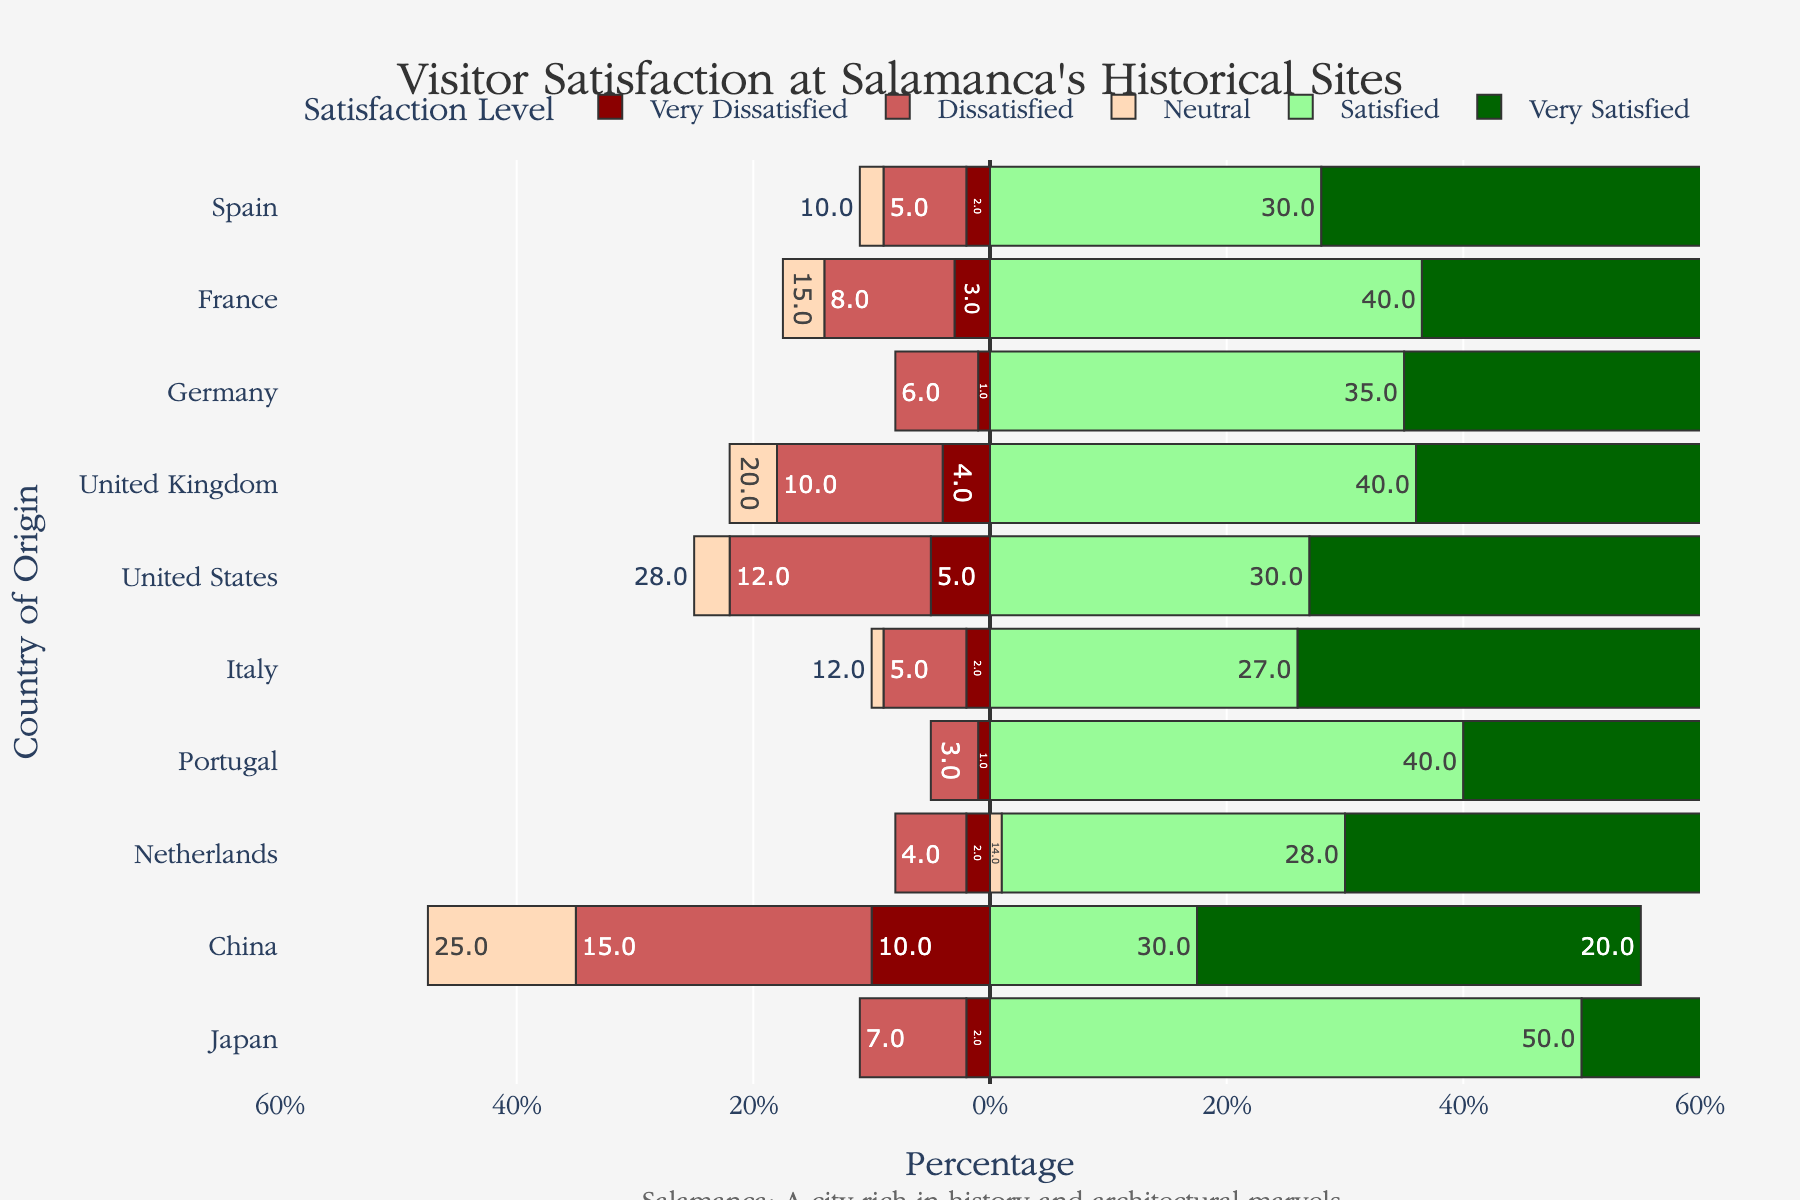How many countries have a higher percentage of Very Satisfied visitors than Satisfied visitors? To find the answer, we need to compare the percentage of Very Satisfied visitors to Satisfied visitors for each country. The countries which have a higher percentage of Very Satisfied visitors than Satisfied are: Spain, Italy, Portugal, and Netherlands.
Answer: 4 Which country has the highest percentage of Very Dissatisfied visitors, and what is the percentage? Identify the bar with the largest negative value for Very Dissatisfied visitors. China has the highest percentage of Very Dissatisfied visitors at 10%.
Answer: China, 10% Among the countries listed, who has the lowest percentage of Neutral visitors? Compare the percentage values of the Neutral visitors for all the countries. Portugal has the lowest percentage of Neutral visitors at 8%.
Answer: Portugal, 8% What is the total percentage of visitors from the United States who are either Satisfied or Very Satisfied? Add the percentages of Satisfied and Very Satisfied visitors from the United States. The sum is 30% + 25% = 55%.
Answer: 55% Which two countries have the closest percentages of Dissatisfied visitors, and what is the difference? Compare the percentages of Dissatisfied visitors for all countries and find two closest values. Spain and Italy both have 5%, which means the difference is 0%.
Answer: Spain and Italy, 0% Rank the countries from highest to lowest based on the percentage of Very Satisfied visitors. List the percentage of Very Satisfied visitors for each country and sort them in descending order: Italy (54%), Spain (53%), Netherlands (52%), Portugal (48%), Germany (44%), France (34%), United Kingdom (26%), Japan (23%), United States (25%), China (20%).
Answer: Italy, Spain, Netherlands, Portugal, Germany, France, United Kingdom, Japan, United States, China Which country has the smallest combined percentage of Very Dissatisfied and Dissatisfied visitors? Add the percentages of Very Dissatisfied and Dissatisfied visitors for each country and identify the smallest sum. Portugal has the smallest combined percentage (1% + 3% = 4%).
Answer: Portugal What's the percentage of neutral visitors from France and Japan combined? Add the percentages of Neutral visitors from France and Japan. The sum is 15% + 18% = 33%.
Answer: 33% Is there any country where the majority of visitors (over 50%) are Very Satisfied? Check each country's percentage of Very Satisfied visitors to see if any exceed 50%. Spain (53%), Italy (54%), and Netherlands (52%) meet this criterion.
Answer: Yes, Spain, Italy, Netherlands How does the percentage of Very Satisfied visitors from Germany compare to that from Japan? Compare the percentages of Very Satisfied visitors from Germany (44%) to Japan (23%). Germany has a higher percentage of Very Satisfied visitors than Japan.
Answer: Germany has a higher percentage 